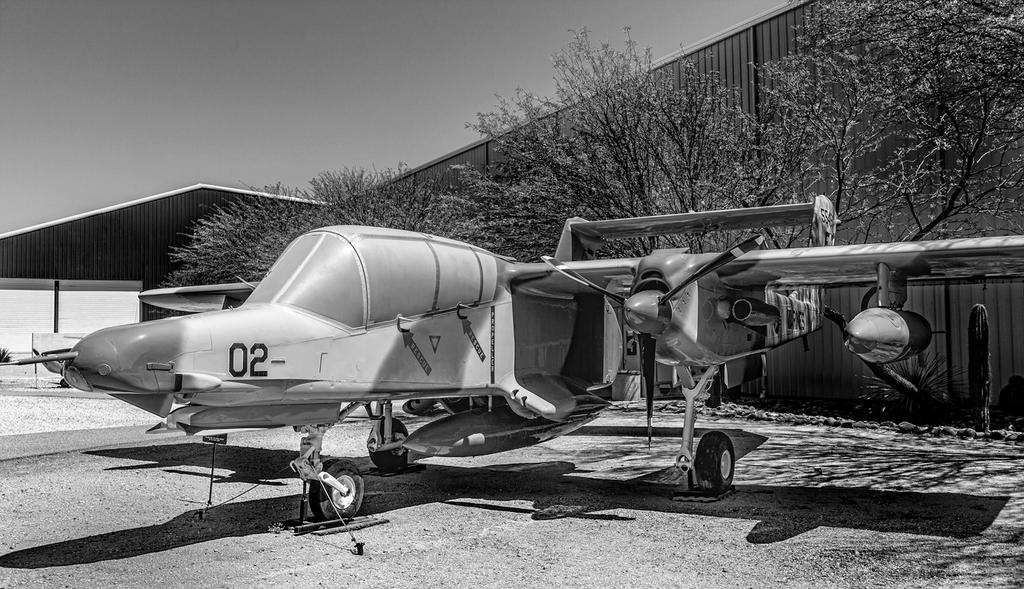What is the id number of the plane?
Ensure brevity in your answer.  02. Is the id number on the front of the plane?
Give a very brief answer. 02. 